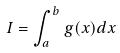Convert formula to latex. <formula><loc_0><loc_0><loc_500><loc_500>I = \int _ { a } ^ { b } g ( x ) d x</formula> 